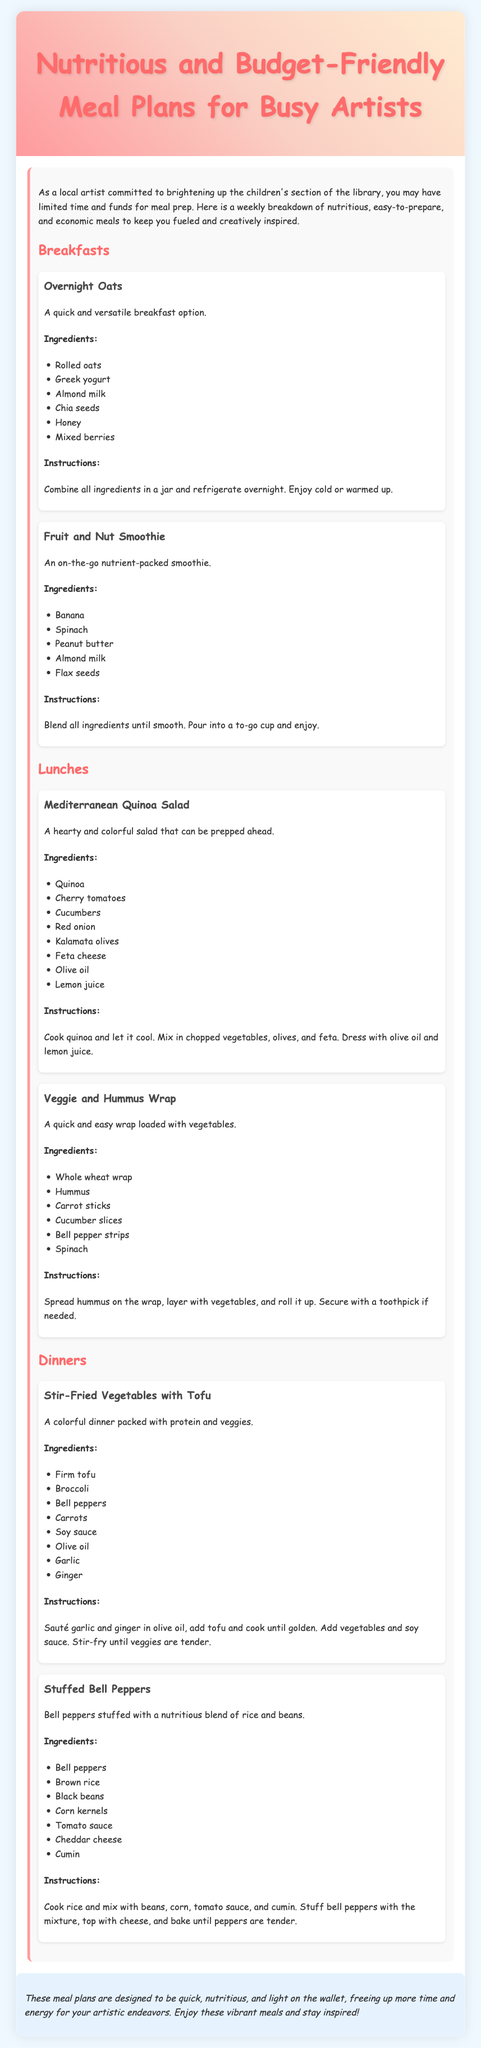what is the title of the document? The title is found in the header section of the document.
Answer: Nutritious and Budget-Friendly Meal Plans for Busy Artists how many breakfast options are provided? The breakfast section includes multiple options listed within its header.
Answer: 2 what is a key ingredient in the Overnight Oats? The key ingredients are specified in the ingredients list for Overnight Oats.
Answer: Greek yogurt what type of wrap is mentioned for lunch? This detail is found under the Lunches section listing the meal types.
Answer: Veggie and Hummus Wrap which meal includes tofu? This can be determined by checking the Dinner section for its mentioned ingredients.
Answer: Stir-Fried Vegetables with Tofu what can be used as a topping for the Stuffed Bell Peppers? The document provides specific details on toppings in the corresponding meal description.
Answer: Cheddar cheese what cooking method is suggested for the Stir-Fried Vegetables? This detail is part of the cooking instructions provided in the dinner section.
Answer: Sauté what color are the bell peppers used in the Stuffed Bell Peppers meal? The color is specified in the ingredients section for that meal.
Answer: Bell peppers 